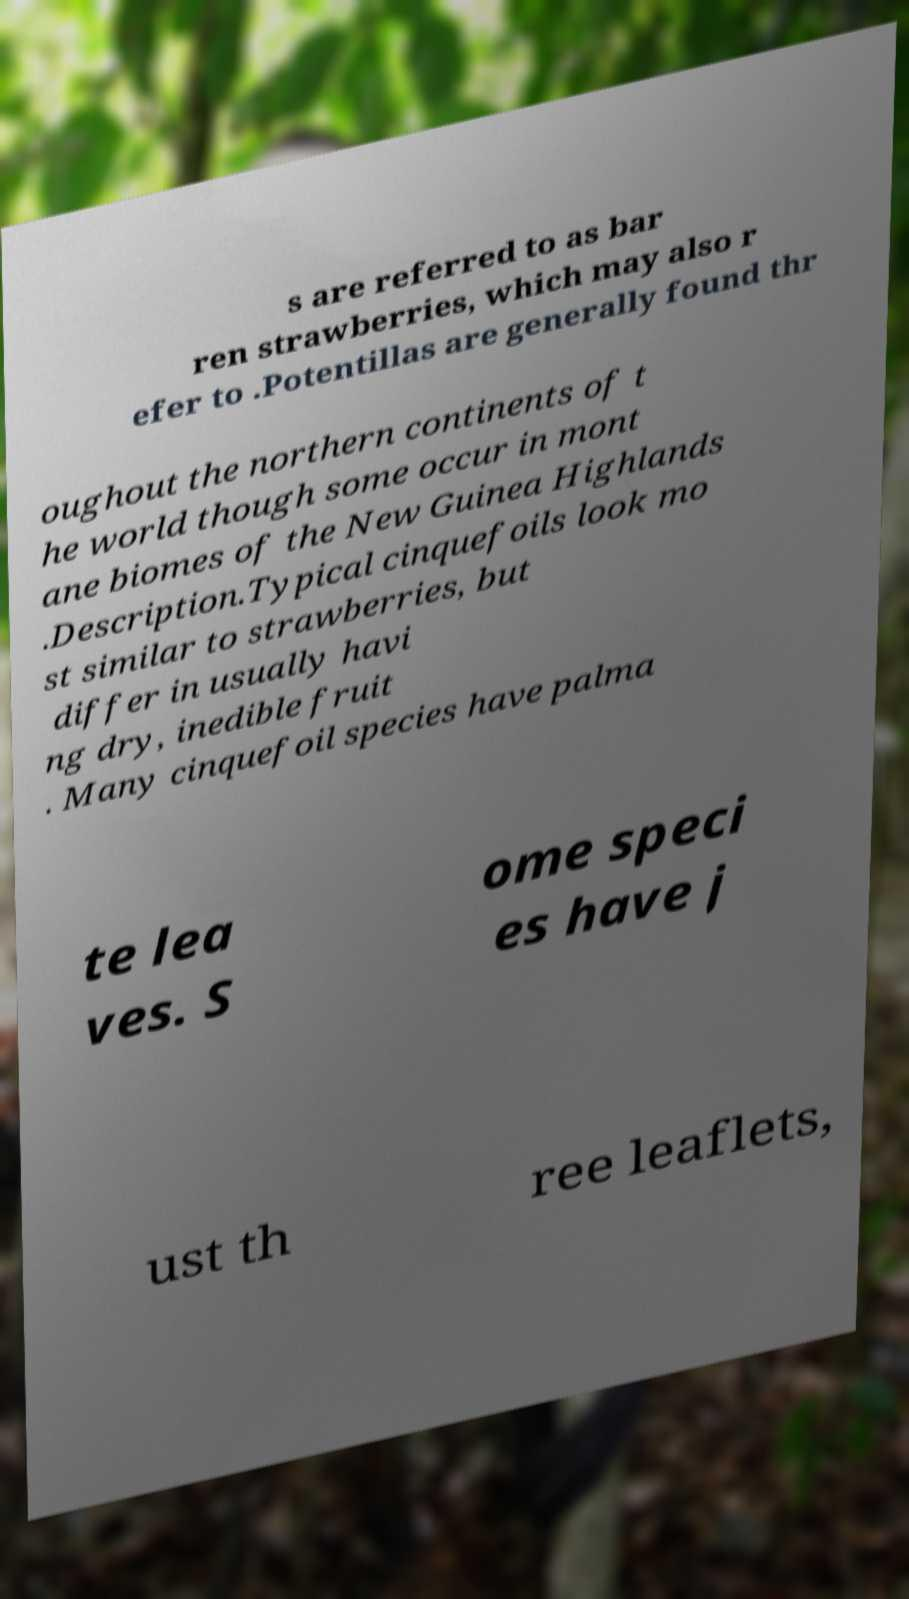I need the written content from this picture converted into text. Can you do that? s are referred to as bar ren strawberries, which may also r efer to .Potentillas are generally found thr oughout the northern continents of t he world though some occur in mont ane biomes of the New Guinea Highlands .Description.Typical cinquefoils look mo st similar to strawberries, but differ in usually havi ng dry, inedible fruit . Many cinquefoil species have palma te lea ves. S ome speci es have j ust th ree leaflets, 